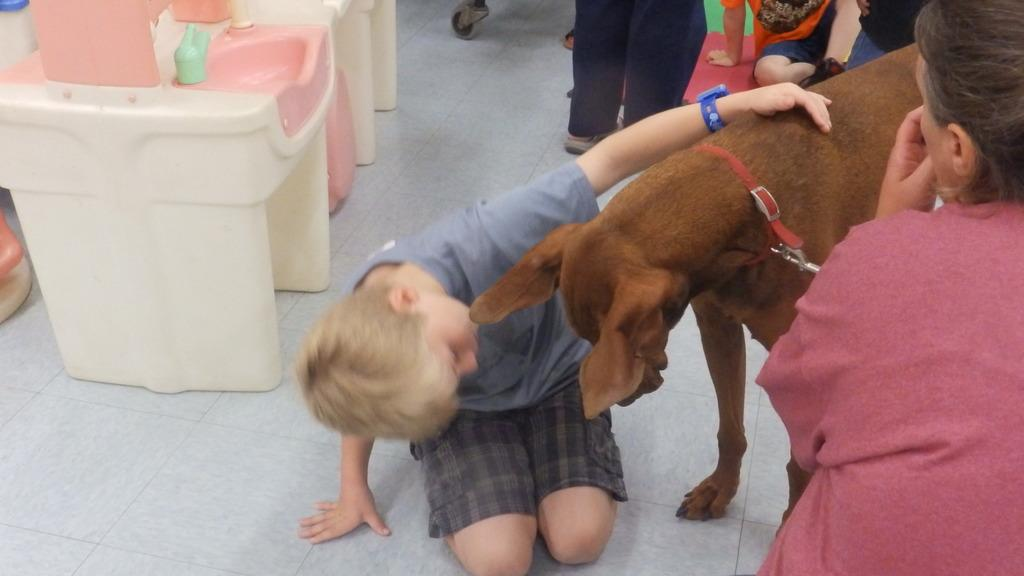Who is the main subject in the image? There is a boy in the image. What is the boy doing in the image? The boy is touching a dog. Can you describe the background of the image? There are other persons in the background of the image. What type of surface is visible in the image? There is a floor visible in the image. What object can be seen in the image that is made of plastic? There is a plastic table or sink in the image. What type of turkey can be seen sitting on the seat in the image? There is no turkey or seat present in the image. What material is the tin used for in the image? There is no tin present in the image. 